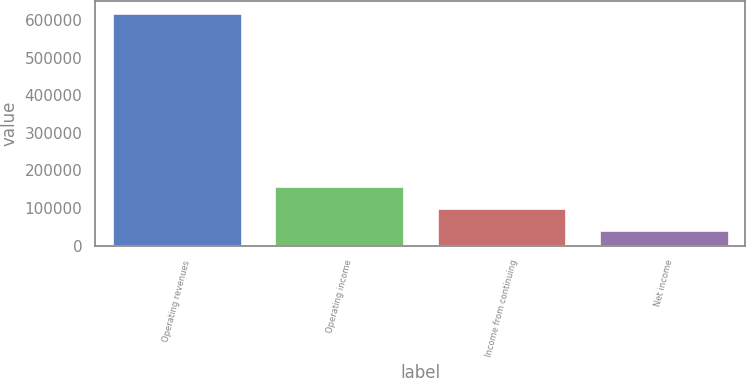Convert chart. <chart><loc_0><loc_0><loc_500><loc_500><bar_chart><fcel>Operating revenues<fcel>Operating income<fcel>Income from continuing<fcel>Net income<nl><fcel>618554<fcel>159738<fcel>99434<fcel>41754<nl></chart> 